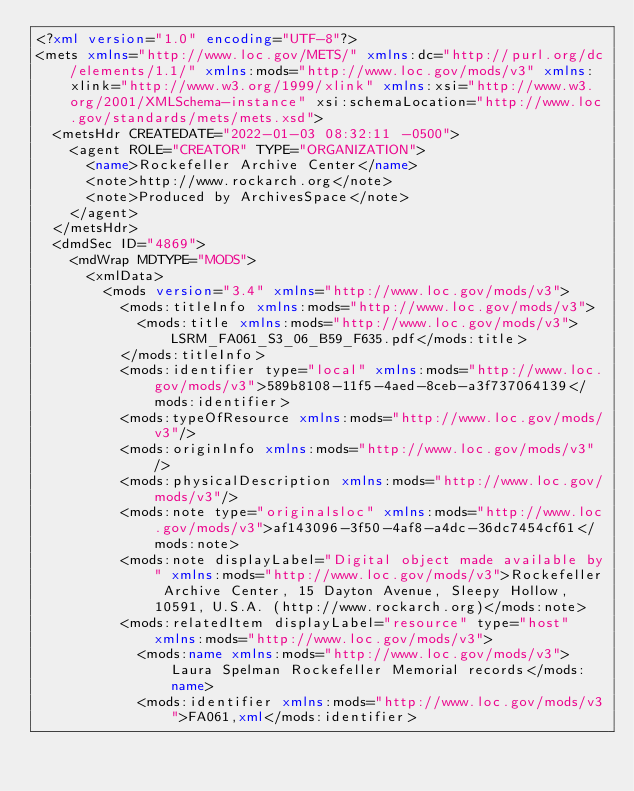<code> <loc_0><loc_0><loc_500><loc_500><_XML_><?xml version="1.0" encoding="UTF-8"?>
<mets xmlns="http://www.loc.gov/METS/" xmlns:dc="http://purl.org/dc/elements/1.1/" xmlns:mods="http://www.loc.gov/mods/v3" xmlns:xlink="http://www.w3.org/1999/xlink" xmlns:xsi="http://www.w3.org/2001/XMLSchema-instance" xsi:schemaLocation="http://www.loc.gov/standards/mets/mets.xsd">
  <metsHdr CREATEDATE="2022-01-03 08:32:11 -0500">
    <agent ROLE="CREATOR" TYPE="ORGANIZATION">
      <name>Rockefeller Archive Center</name>
      <note>http://www.rockarch.org</note>
      <note>Produced by ArchivesSpace</note>
    </agent>
  </metsHdr>
  <dmdSec ID="4869">
    <mdWrap MDTYPE="MODS">
      <xmlData>
        <mods version="3.4" xmlns="http://www.loc.gov/mods/v3">
          <mods:titleInfo xmlns:mods="http://www.loc.gov/mods/v3">
            <mods:title xmlns:mods="http://www.loc.gov/mods/v3">LSRM_FA061_S3_06_B59_F635.pdf</mods:title>
          </mods:titleInfo>
          <mods:identifier type="local" xmlns:mods="http://www.loc.gov/mods/v3">589b8108-11f5-4aed-8ceb-a3f737064139</mods:identifier>
          <mods:typeOfResource xmlns:mods="http://www.loc.gov/mods/v3"/>
          <mods:originInfo xmlns:mods="http://www.loc.gov/mods/v3"/>
          <mods:physicalDescription xmlns:mods="http://www.loc.gov/mods/v3"/>
          <mods:note type="originalsloc" xmlns:mods="http://www.loc.gov/mods/v3">af143096-3f50-4af8-a4dc-36dc7454cf61</mods:note>
          <mods:note displayLabel="Digital object made available by" xmlns:mods="http://www.loc.gov/mods/v3">Rockefeller Archive Center, 15 Dayton Avenue, Sleepy Hollow, 10591, U.S.A. (http://www.rockarch.org)</mods:note>
          <mods:relatedItem displayLabel="resource" type="host" xmlns:mods="http://www.loc.gov/mods/v3">
            <mods:name xmlns:mods="http://www.loc.gov/mods/v3">Laura Spelman Rockefeller Memorial records</mods:name>
            <mods:identifier xmlns:mods="http://www.loc.gov/mods/v3">FA061,xml</mods:identifier></code> 